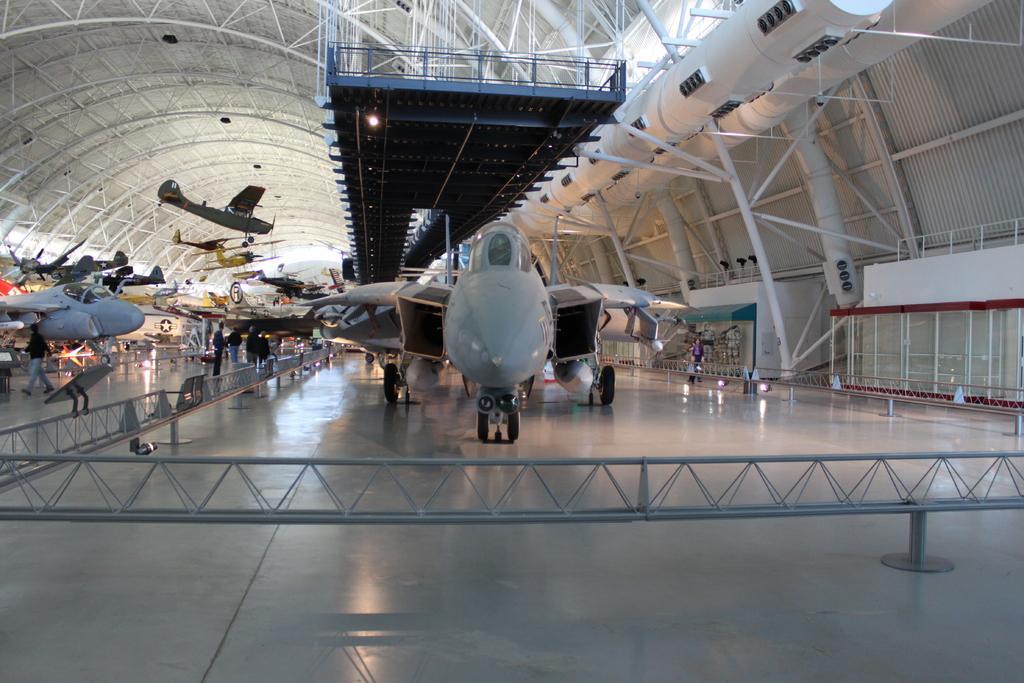Can you describe this image briefly? In the middle it's an aeroplane which is in grey color. On the left side there are other aeroplanes. 